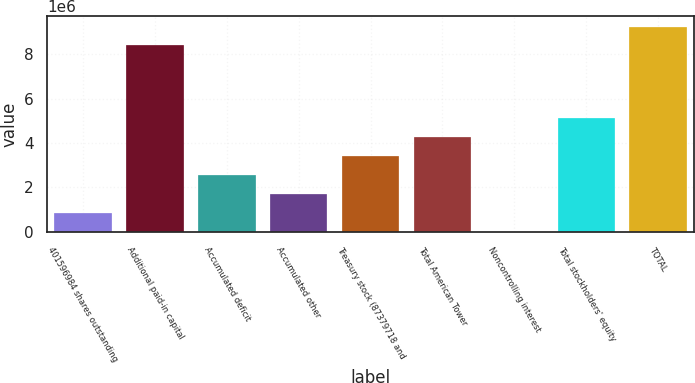Convert chart. <chart><loc_0><loc_0><loc_500><loc_500><bar_chart><fcel>401596984 shares outstanding<fcel>Additional paid-in capital<fcel>Accumulated deficit<fcel>Accumulated other<fcel>Treasury stock (87379718 and<fcel>Total American Tower<fcel>Noncontrolling interest<fcel>Total stockholders' equity<fcel>TOTAL<nl><fcel>854732<fcel>8.39364e+06<fcel>2.55811e+06<fcel>1.70642e+06<fcel>3.4098e+06<fcel>4.26149e+06<fcel>3043<fcel>5.11318e+06<fcel>9.24533e+06<nl></chart> 